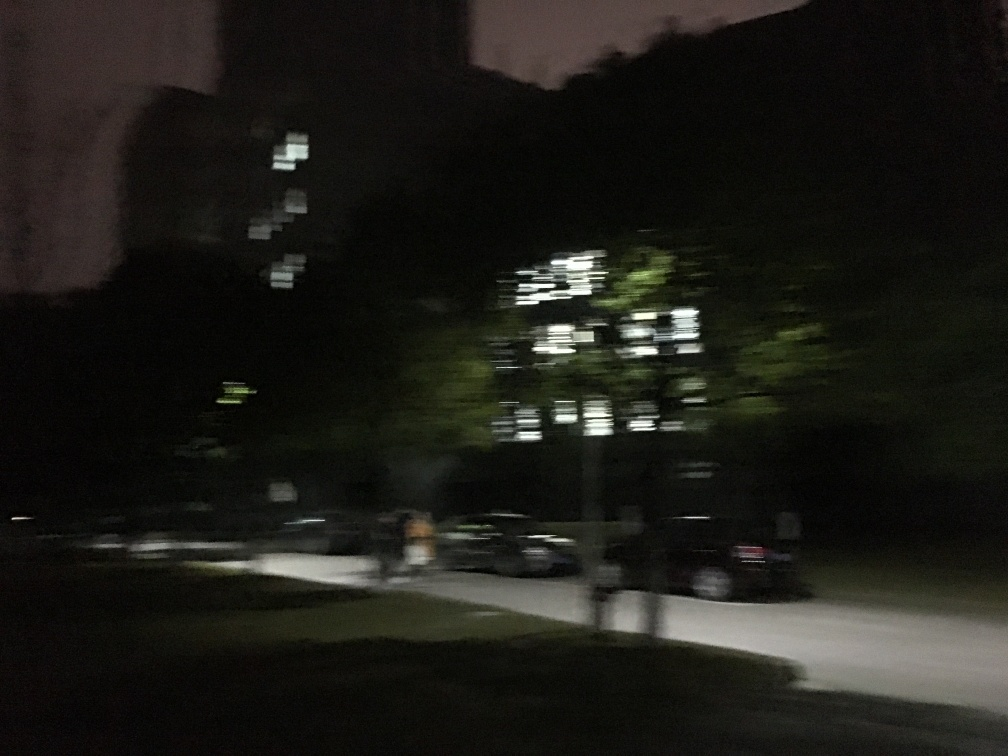What improvements could be made when taking a similar picture in the future? To enhance the quality of a similar picture, it would be beneficial to use a tripod or stable surface to prevent camera shake and achieve a sharper image. Increasing the ISO setting can allow for a brighter exposure in low-light conditions, albeit at the risk of added noise. Using a slower shutter speed could capture more light and detail, but this must be balanced against the movement of the subject to avoid motion blur. Additionally, selecting an aperture that allows for the desired depth of field while letting enough light reach the sensor could significantly improve the outcome. Experimenting with these settings in combination with the camera's photo editing features or software corrections post-capture would lead to a more visually appealing and clear image. 